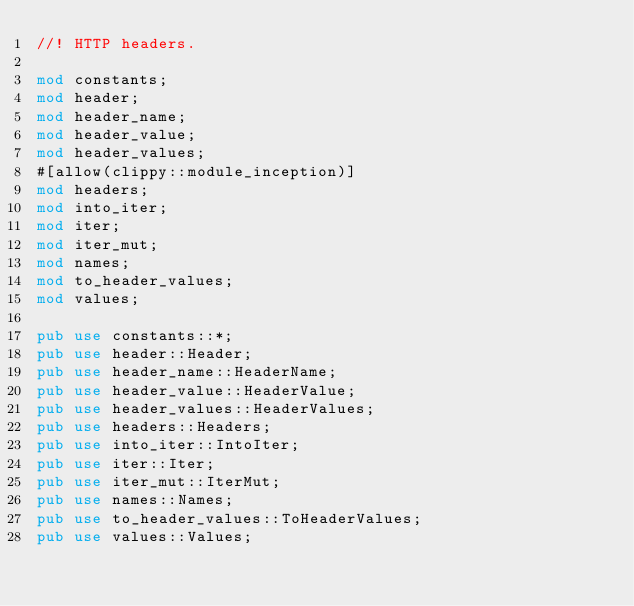<code> <loc_0><loc_0><loc_500><loc_500><_Rust_>//! HTTP headers.

mod constants;
mod header;
mod header_name;
mod header_value;
mod header_values;
#[allow(clippy::module_inception)]
mod headers;
mod into_iter;
mod iter;
mod iter_mut;
mod names;
mod to_header_values;
mod values;

pub use constants::*;
pub use header::Header;
pub use header_name::HeaderName;
pub use header_value::HeaderValue;
pub use header_values::HeaderValues;
pub use headers::Headers;
pub use into_iter::IntoIter;
pub use iter::Iter;
pub use iter_mut::IterMut;
pub use names::Names;
pub use to_header_values::ToHeaderValues;
pub use values::Values;
</code> 